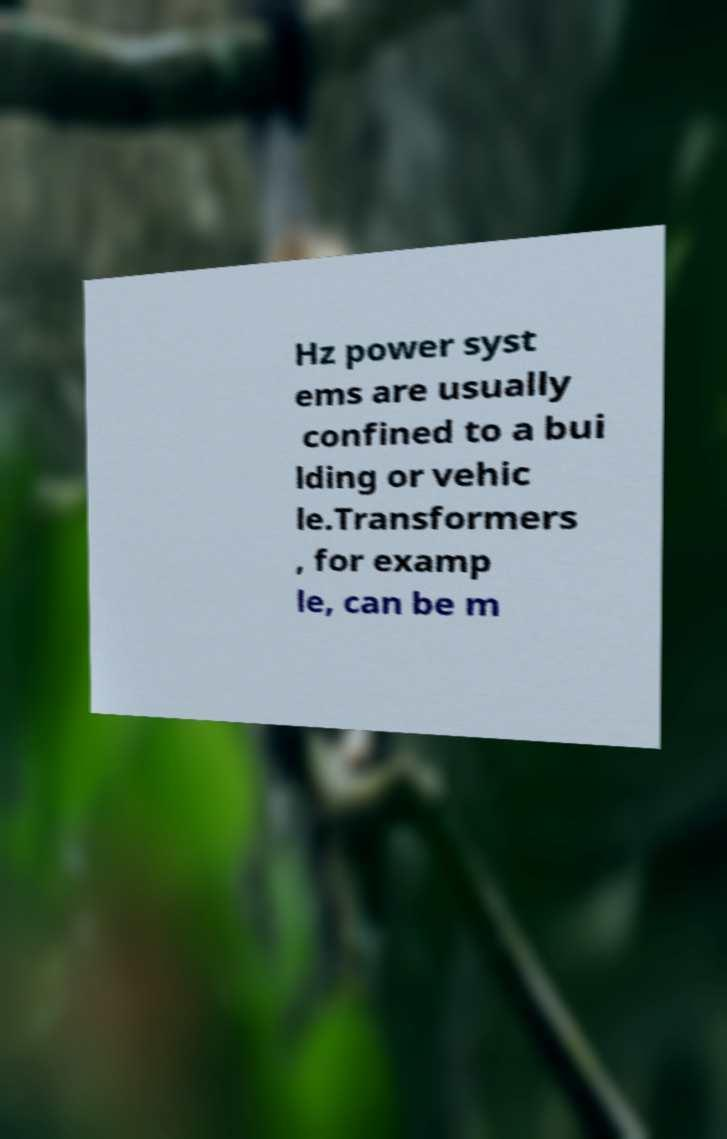Please read and relay the text visible in this image. What does it say? Hz power syst ems are usually confined to a bui lding or vehic le.Transformers , for examp le, can be m 